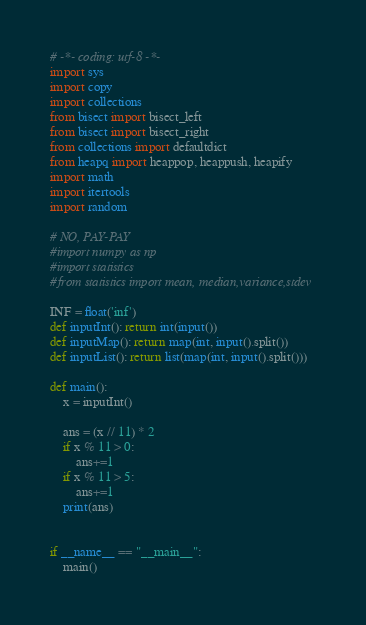<code> <loc_0><loc_0><loc_500><loc_500><_Python_># -*- coding: utf-8 -*-
import sys
import copy
import collections
from bisect import bisect_left
from bisect import bisect_right
from collections import defaultdict
from heapq import heappop, heappush, heapify
import math
import itertools
import random
 
# NO, PAY-PAY
#import numpy as np
#import statistics
#from statistics import mean, median,variance,stdev
 
INF = float('inf')
def inputInt(): return int(input())
def inputMap(): return map(int, input().split())
def inputList(): return list(map(int, input().split()))
 
def main():
    x = inputInt()
    
    ans = (x // 11) * 2
    if x % 11 > 0:
        ans+=1
    if x % 11 > 5:
        ans+=1
    print(ans)
            
            
if __name__ == "__main__":
	main()
</code> 